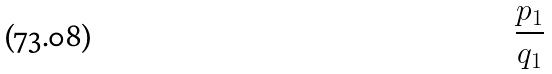Convert formula to latex. <formula><loc_0><loc_0><loc_500><loc_500>\frac { p _ { 1 } } { q _ { 1 } }</formula> 